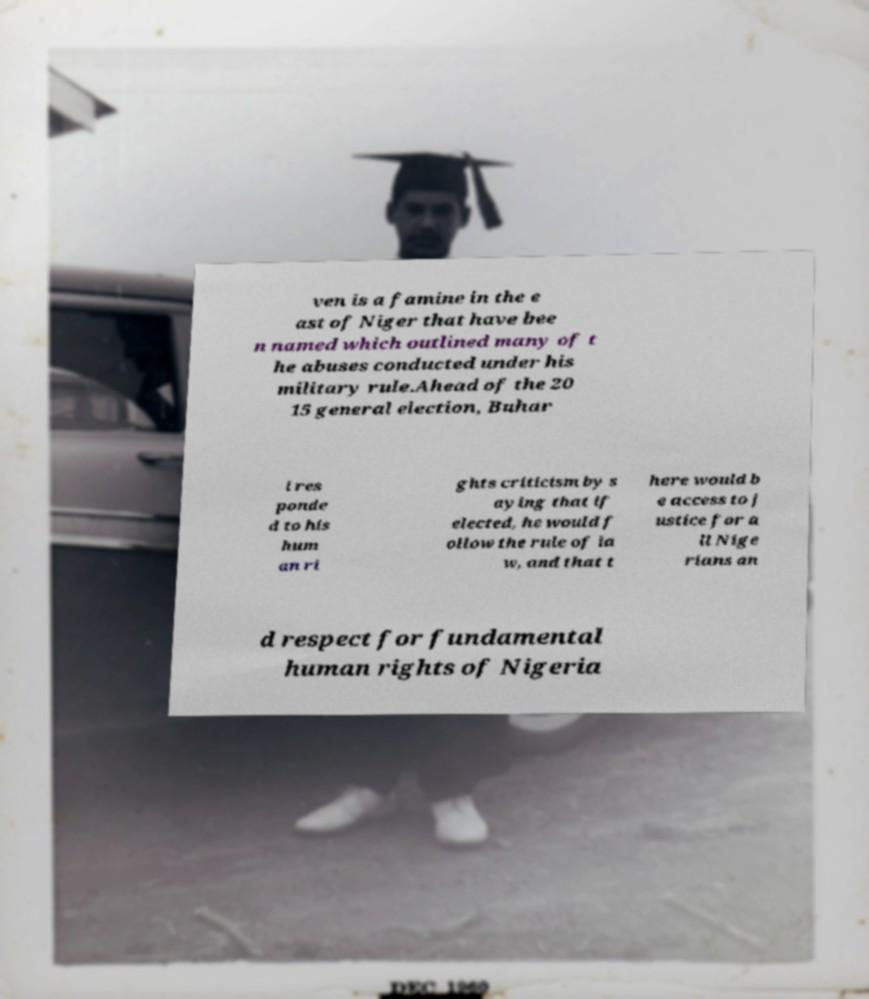Can you accurately transcribe the text from the provided image for me? ven is a famine in the e ast of Niger that have bee n named which outlined many of t he abuses conducted under his military rule.Ahead of the 20 15 general election, Buhar i res ponde d to his hum an ri ghts criticism by s aying that if elected, he would f ollow the rule of la w, and that t here would b e access to j ustice for a ll Nige rians an d respect for fundamental human rights of Nigeria 